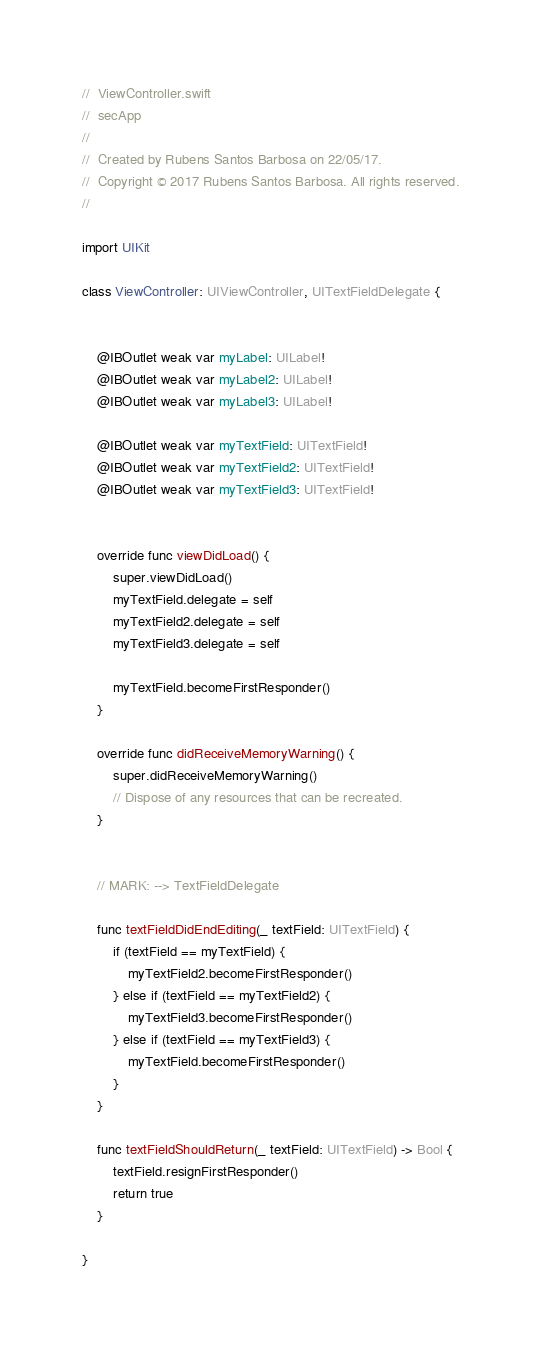Convert code to text. <code><loc_0><loc_0><loc_500><loc_500><_Swift_>//  ViewController.swift
//  secApp
//
//  Created by Rubens Santos Barbosa on 22/05/17.
//  Copyright © 2017 Rubens Santos Barbosa. All rights reserved.
//

import UIKit

class ViewController: UIViewController, UITextFieldDelegate {
    
    
    @IBOutlet weak var myLabel: UILabel!
    @IBOutlet weak var myLabel2: UILabel!
    @IBOutlet weak var myLabel3: UILabel!
    
    @IBOutlet weak var myTextField: UITextField!
    @IBOutlet weak var myTextField2: UITextField!
    @IBOutlet weak var myTextField3: UITextField!
    

    override func viewDidLoad() {
        super.viewDidLoad()
        myTextField.delegate = self
        myTextField2.delegate = self
        myTextField3.delegate = self
        
        myTextField.becomeFirstResponder()
    }

    override func didReceiveMemoryWarning() {
        super.didReceiveMemoryWarning()
        // Dispose of any resources that can be recreated.
    }


    // MARK: --> TextFieldDelegate
    
    func textFieldDidEndEditing(_ textField: UITextField) {
        if (textField == myTextField) {
            myTextField2.becomeFirstResponder()
        } else if (textField == myTextField2) {
            myTextField3.becomeFirstResponder()
        } else if (textField == myTextField3) {
            myTextField.becomeFirstResponder()
        }
    }
    
    func textFieldShouldReturn(_ textField: UITextField) -> Bool {
        textField.resignFirstResponder()
        return true
    }
    
}

</code> 